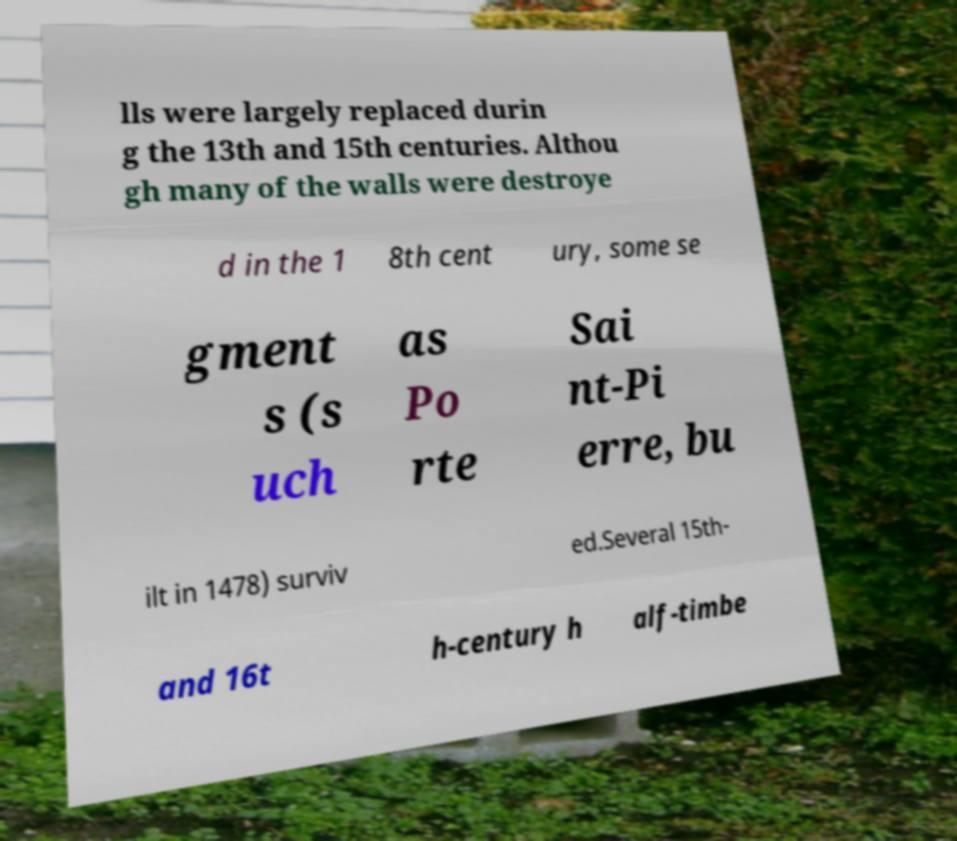Could you assist in decoding the text presented in this image and type it out clearly? lls were largely replaced durin g the 13th and 15th centuries. Althou gh many of the walls were destroye d in the 1 8th cent ury, some se gment s (s uch as Po rte Sai nt-Pi erre, bu ilt in 1478) surviv ed.Several 15th- and 16t h-century h alf-timbe 